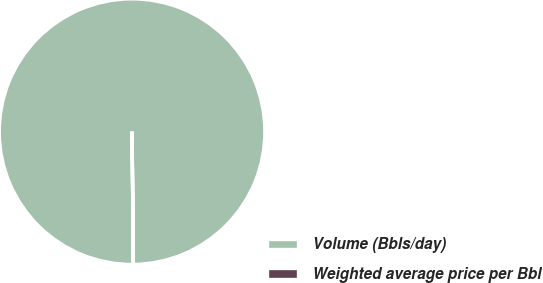<chart> <loc_0><loc_0><loc_500><loc_500><pie_chart><fcel>Volume (Bbls/day)<fcel>Weighted average price per Bbl<nl><fcel>99.99%<fcel>0.01%<nl></chart> 